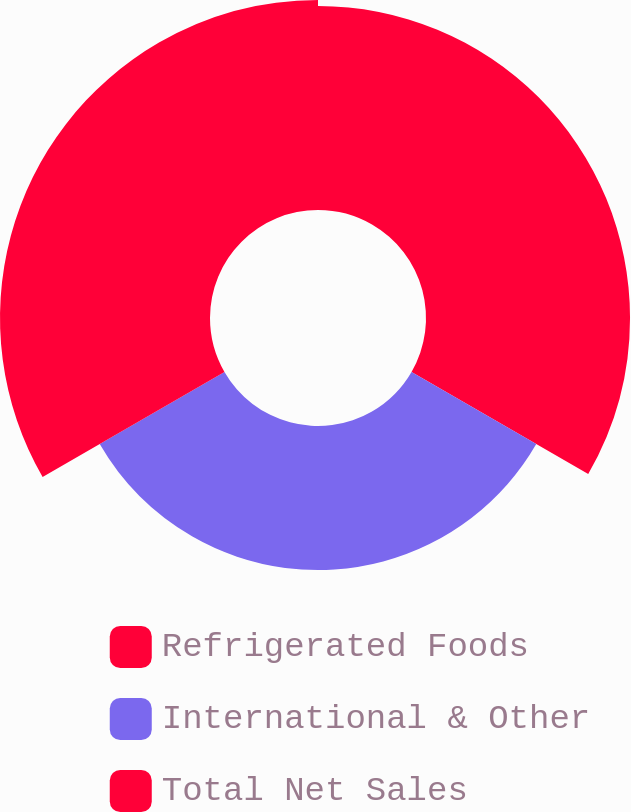Convert chart. <chart><loc_0><loc_0><loc_500><loc_500><pie_chart><fcel>Refrigerated Foods<fcel>International & Other<fcel>Total Net Sales<nl><fcel>36.56%<fcel>25.81%<fcel>37.63%<nl></chart> 